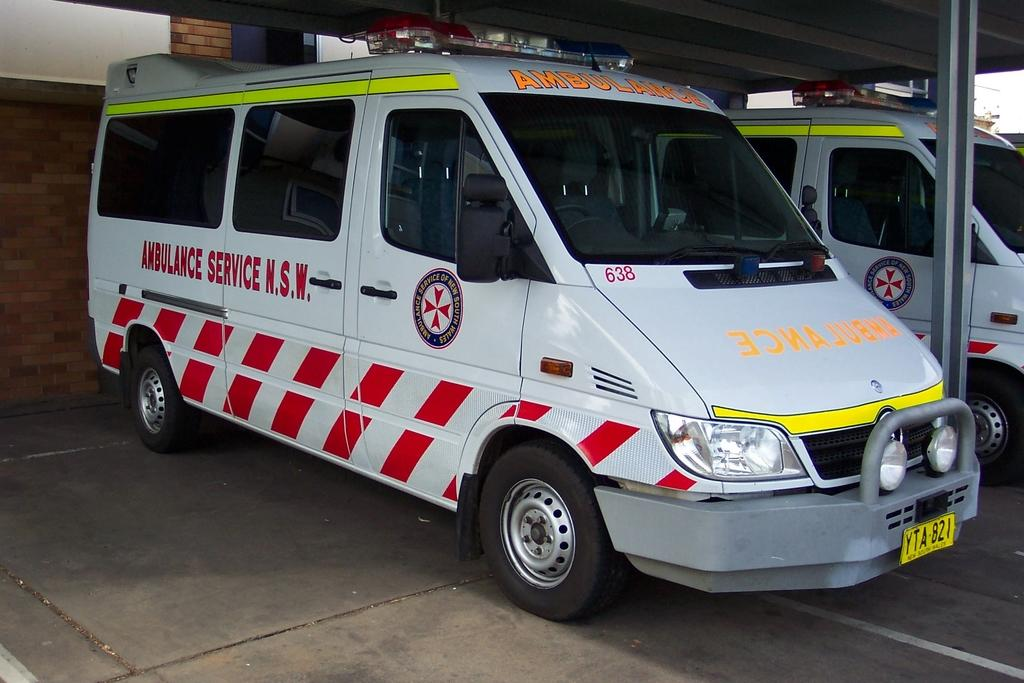Provide a one-sentence caption for the provided image. a van that is functioning as an ambulance, it is mostly white. 